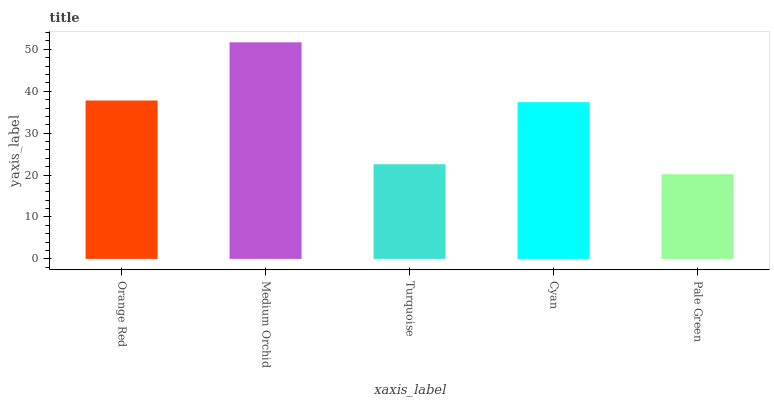Is Pale Green the minimum?
Answer yes or no. Yes. Is Medium Orchid the maximum?
Answer yes or no. Yes. Is Turquoise the minimum?
Answer yes or no. No. Is Turquoise the maximum?
Answer yes or no. No. Is Medium Orchid greater than Turquoise?
Answer yes or no. Yes. Is Turquoise less than Medium Orchid?
Answer yes or no. Yes. Is Turquoise greater than Medium Orchid?
Answer yes or no. No. Is Medium Orchid less than Turquoise?
Answer yes or no. No. Is Cyan the high median?
Answer yes or no. Yes. Is Cyan the low median?
Answer yes or no. Yes. Is Turquoise the high median?
Answer yes or no. No. Is Turquoise the low median?
Answer yes or no. No. 